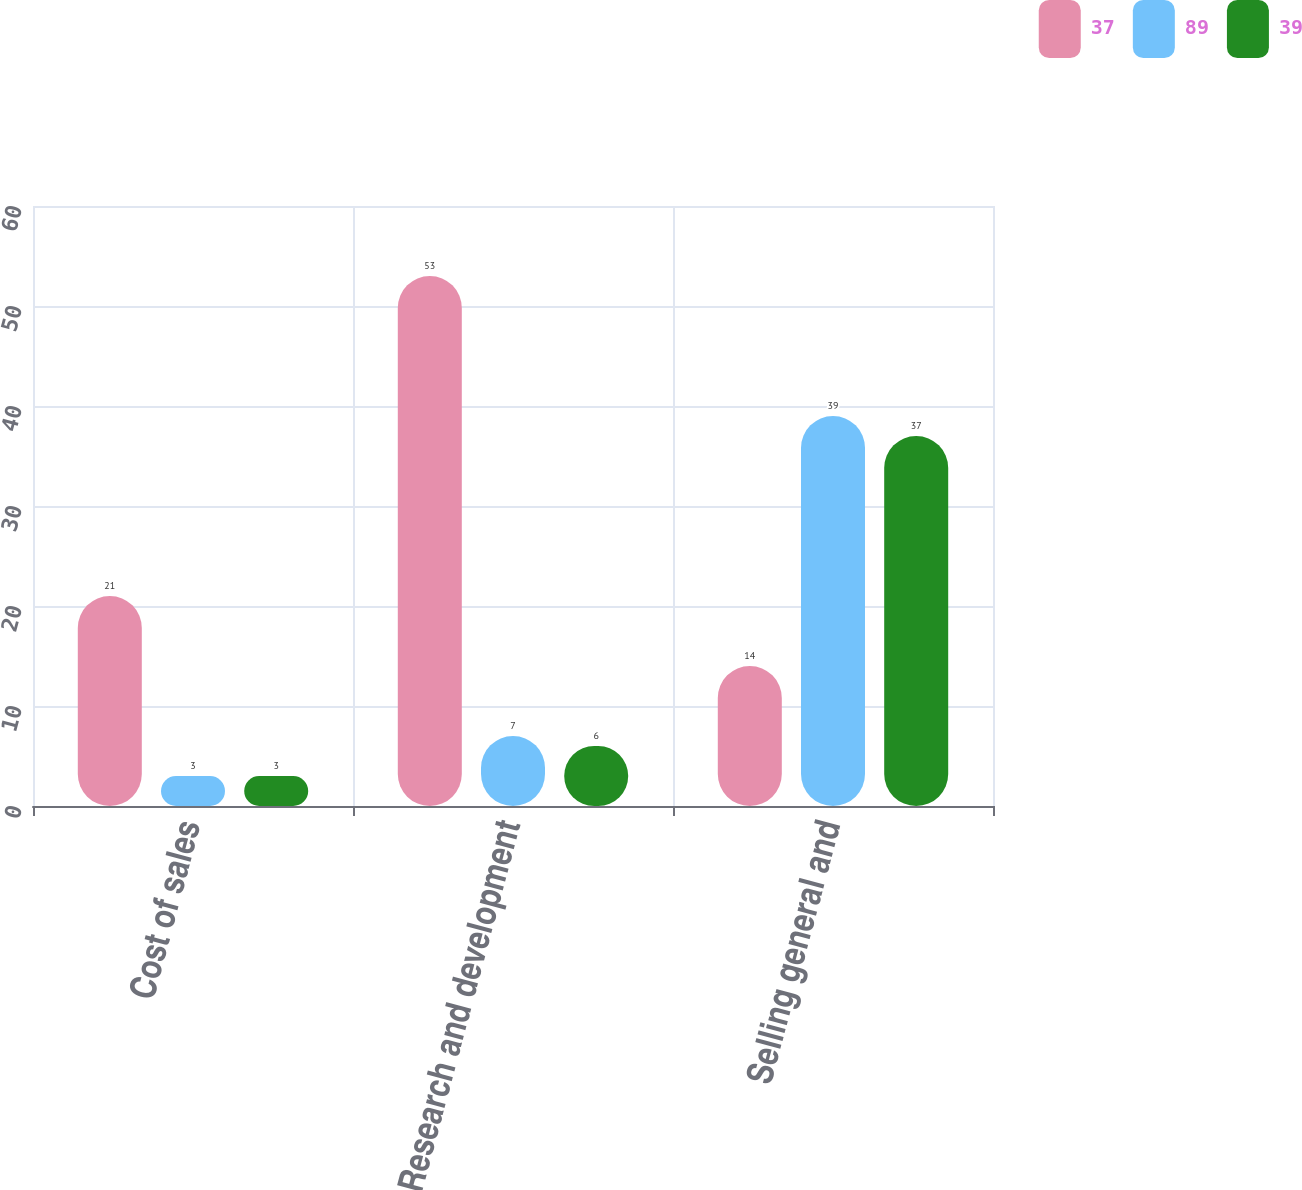<chart> <loc_0><loc_0><loc_500><loc_500><stacked_bar_chart><ecel><fcel>Cost of sales<fcel>Research and development<fcel>Selling general and<nl><fcel>37<fcel>21<fcel>53<fcel>14<nl><fcel>89<fcel>3<fcel>7<fcel>39<nl><fcel>39<fcel>3<fcel>6<fcel>37<nl></chart> 